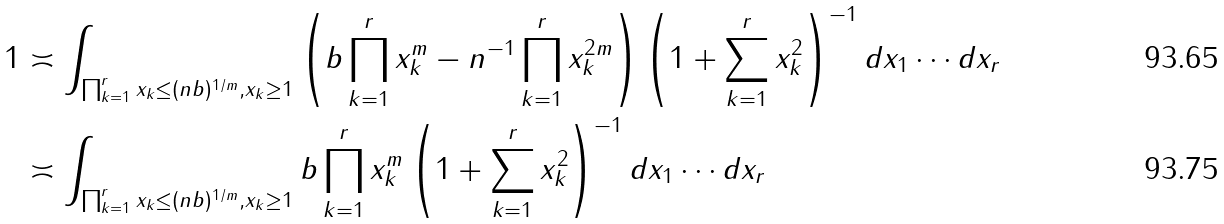<formula> <loc_0><loc_0><loc_500><loc_500>1 & \asymp \int _ { \prod _ { k = 1 } ^ { r } x _ { k } \leq ( n b ) ^ { 1 / m } , x _ { k } \geq 1 } \left ( b \prod _ { k = 1 } ^ { r } x _ { k } ^ { m } - n ^ { - 1 } \prod _ { k = 1 } ^ { r } x _ { k } ^ { 2 m } \right ) \left ( 1 + \sum _ { k = 1 } ^ { r } x _ { k } ^ { 2 } \right ) ^ { - 1 } d x _ { 1 } \cdots d x _ { r } \\ & \asymp \int _ { \prod _ { k = 1 } ^ { r } x _ { k } \leq ( n b ) ^ { 1 / m } , x _ { k } \geq 1 } b \prod _ { k = 1 } ^ { r } x _ { k } ^ { m } \left ( 1 + \sum _ { k = 1 } ^ { r } x _ { k } ^ { 2 } \right ) ^ { - 1 } d x _ { 1 } \cdots d x _ { r }</formula> 